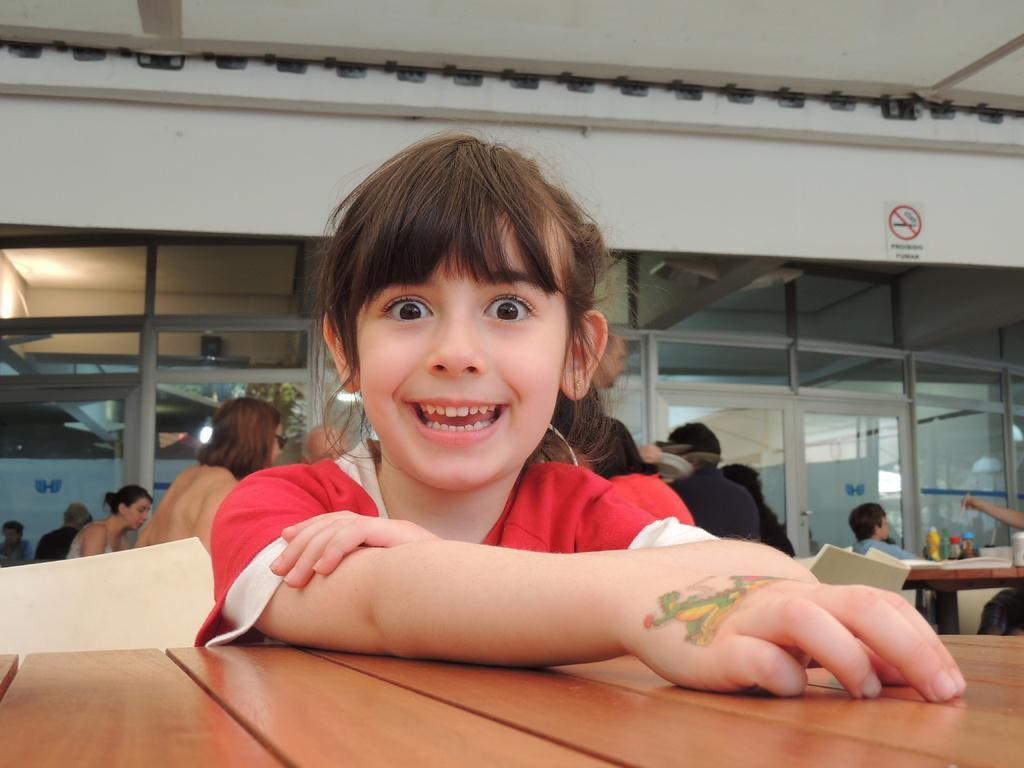Please provide a concise description of this image. This picture shows a girl seated and smiling and we see few people seated on the chairs and we see a table. 